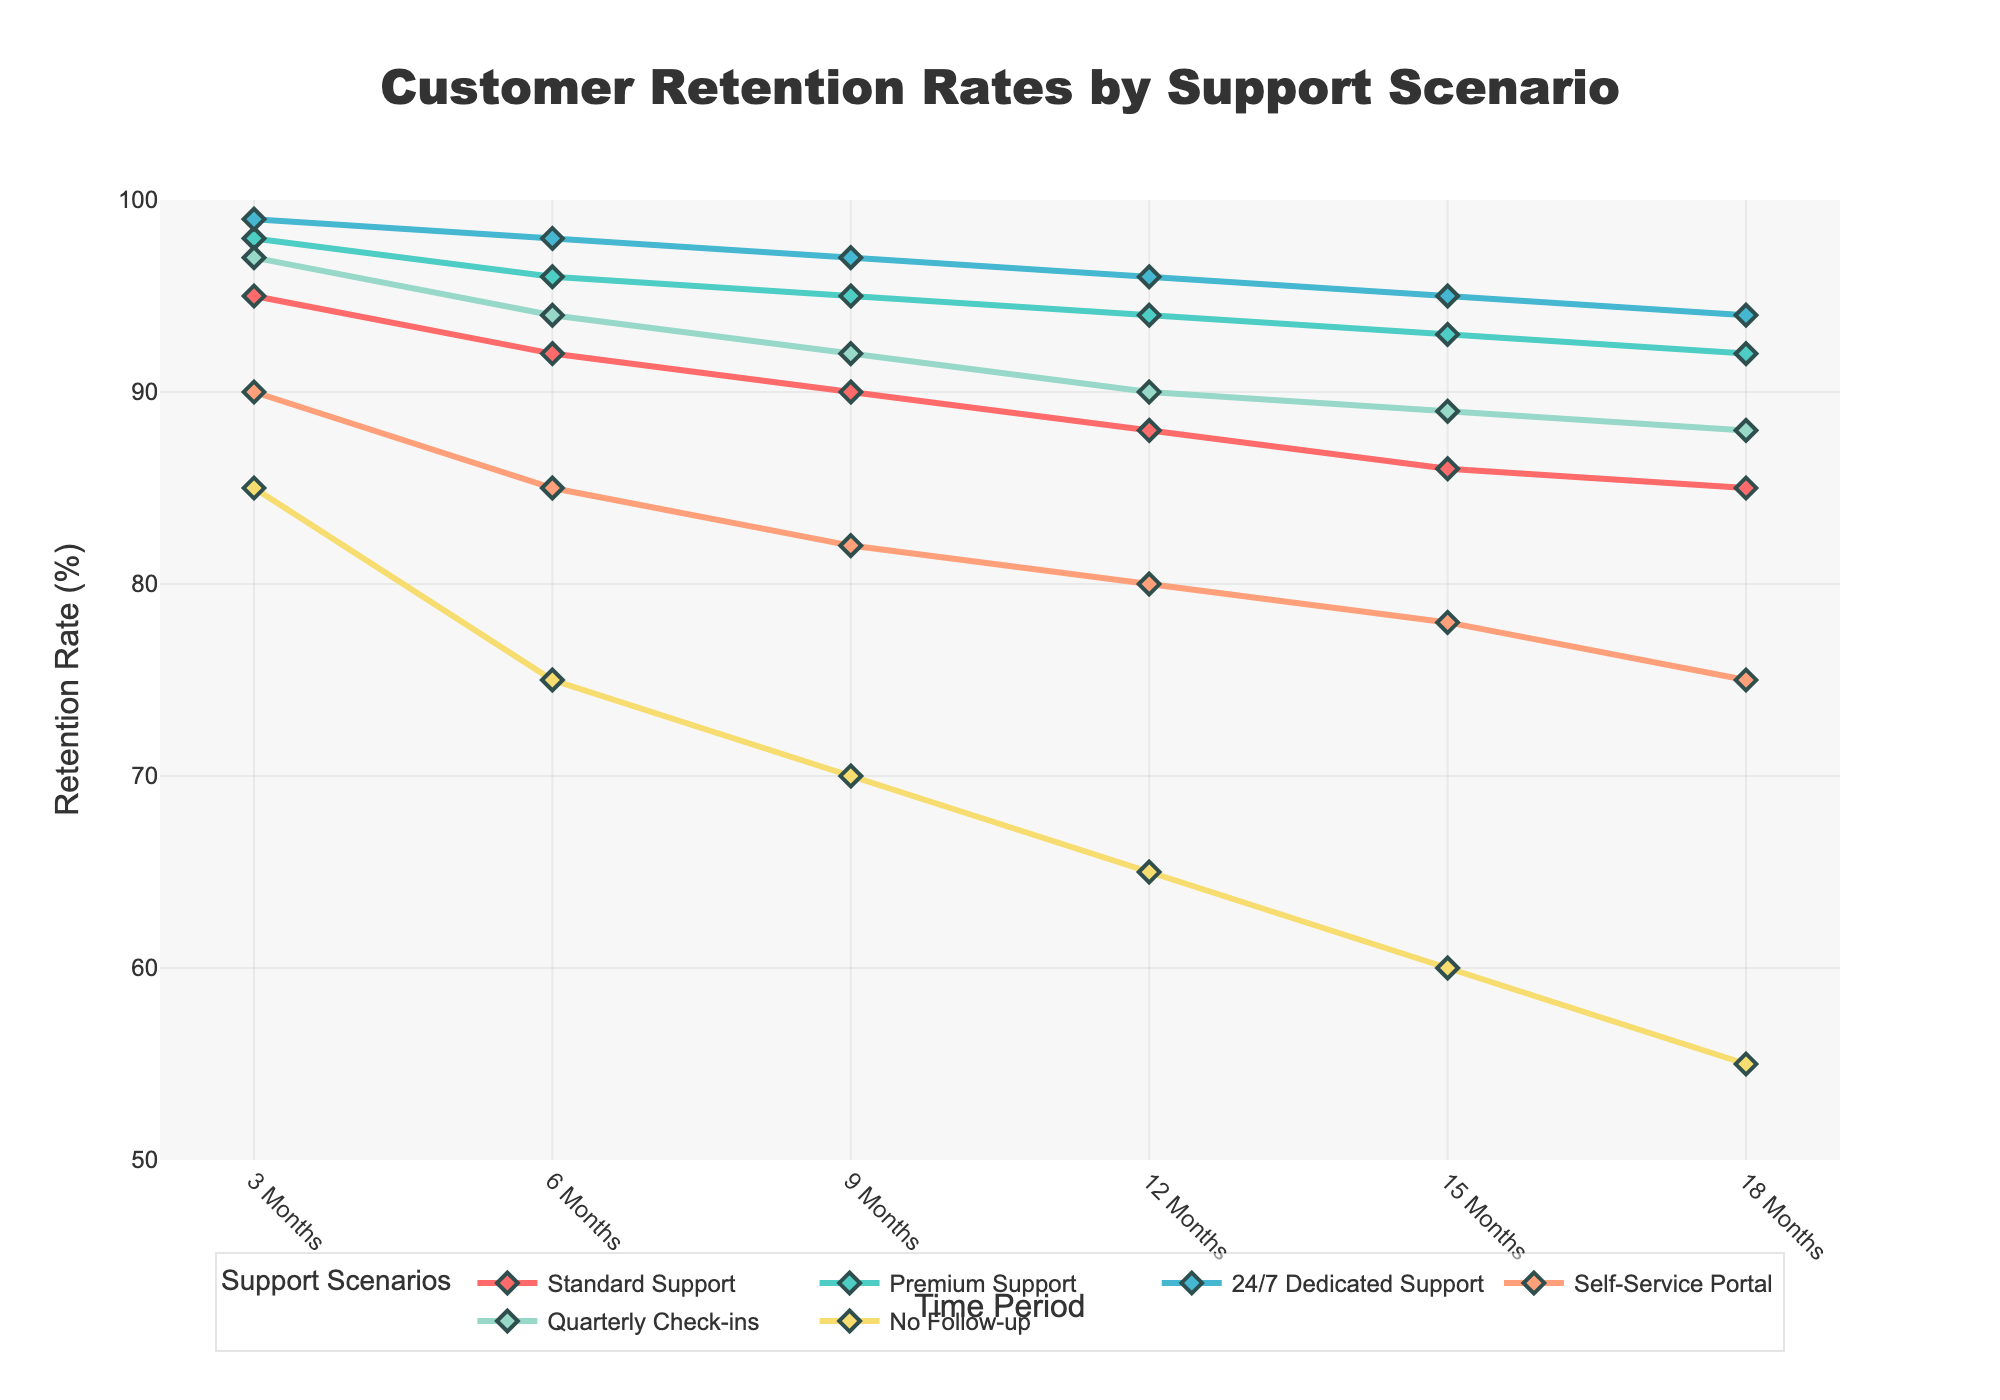What's the title of the chart? The title is typically located at the top of the chart. By reading it, one can understand the main focus of the visualization.
Answer: Customer Retention Rates by Support Scenario What is the x-axis labeled as? The x-axis label can usually be found below the horizontal axis, indicating what the axis represents in the chart.
Answer: Time Period What retention rate does "Standard Support" have at 6 months? Look at the "Standard Support" line, find the data point corresponding to 6 months on the x-axis, and read the y-axis value for that point.
Answer: 92 How much higher is the retention rate for "Premium Support" compared to "Self-Service Portal" at 9 months? Find the retention rate for both "Premium Support" (95%) and "Self-Service Portal" (82%) at 9 months, then subtract the latter from the former: 95% - 82% = 13%.
Answer: 13% Which support scenario shows the highest retention rate at 18 months? Locate the 18-month mark on the x-axis and compare the y-values of all the lines at that point to determine which one is the highest.
Answer: 24/7 Dedicated Support By how much does the retention rate for "No Follow-up" decrease from 3 months to 15 months? Identify the retention rates for "No Follow-up" at 3 months (85%) and 15 months (60%), then subtract the latter from the former: 85% - 60% = 25%.
Answer: 25% What is the average retention rate for "Quarterly Check-ins" over the 6-month period? Add up the retention rates for "Quarterly Check-ins" at 3 months (97%), 6 months (94%), and 9 months (92%), then divide by 3: (97% + 94% + 92%) / 3 = 94.33%.
Answer: 94.33% Which support scenarios have a retention rate of 80% at any time period? Check each line in the fan chart to see if any of them have a data point reaching 80% at any time period. Both "Self-Service Portal" at 12 months and "No Follow-up" at 3 months display this value.
Answer: Self-Service Portal, No Follow-up What is the retention rate gap between "Standard Support" and "24/7 Dedicated Support" at 12 months? Find the retention rates for both "Standard Support" (88%) and "24/7 Dedicated Support" (96%) at 12 months, and then calculate the difference: 96% - 88% = 8%.
Answer: 8% How does "Self-Service Portal" retention change from 6 months to 9 months compared to "Quarterly Check-ins"? Find the changes in retention for both "Self-Service Portal" from 85% to 82% (a 3% decrease) and "Quarterly Check-ins" from 94% to 92% (a 2% decrease) from 6 to 9 months, and compare the two differences.
Answer: Self-Service Portal decreases more 